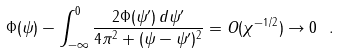Convert formula to latex. <formula><loc_0><loc_0><loc_500><loc_500>\Phi ( \psi ) - \int _ { - \infty } ^ { 0 } \frac { 2 \Phi ( \psi ^ { \prime } ) \, d \psi ^ { \prime } } { 4 \pi ^ { 2 } + ( \psi - \psi ^ { \prime } ) ^ { 2 } } = O ( \chi ^ { - 1 / 2 } ) \to 0 \ .</formula> 